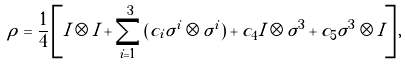<formula> <loc_0><loc_0><loc_500><loc_500>\rho = \frac { 1 } { 4 } \left [ I \otimes I + \sum _ { i = 1 } ^ { 3 } \left ( c _ { i } \sigma ^ { i } \otimes \sigma ^ { i } \right ) + c _ { 4 } I \otimes \sigma ^ { 3 } + c _ { 5 } \sigma ^ { 3 } \otimes I \right ] ,</formula> 